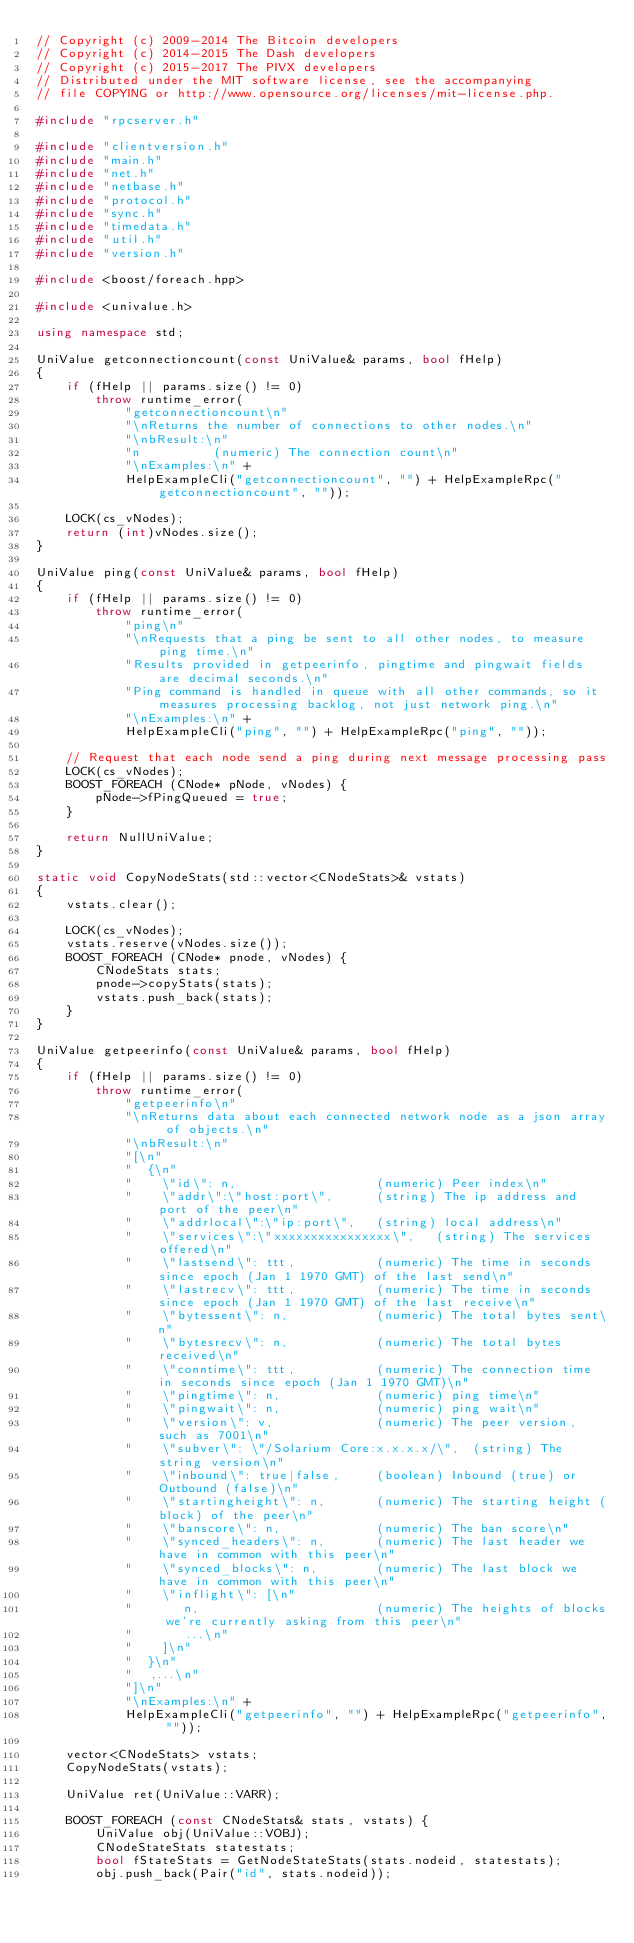Convert code to text. <code><loc_0><loc_0><loc_500><loc_500><_C++_>// Copyright (c) 2009-2014 The Bitcoin developers
// Copyright (c) 2014-2015 The Dash developers
// Copyright (c) 2015-2017 The PIVX developers
// Distributed under the MIT software license, see the accompanying
// file COPYING or http://www.opensource.org/licenses/mit-license.php.

#include "rpcserver.h"

#include "clientversion.h"
#include "main.h"
#include "net.h"
#include "netbase.h"
#include "protocol.h"
#include "sync.h"
#include "timedata.h"
#include "util.h"
#include "version.h"

#include <boost/foreach.hpp>

#include <univalue.h>

using namespace std;

UniValue getconnectioncount(const UniValue& params, bool fHelp)
{
    if (fHelp || params.size() != 0)
        throw runtime_error(
            "getconnectioncount\n"
            "\nReturns the number of connections to other nodes.\n"
            "\nbResult:\n"
            "n          (numeric) The connection count\n"
            "\nExamples:\n" +
            HelpExampleCli("getconnectioncount", "") + HelpExampleRpc("getconnectioncount", ""));

    LOCK(cs_vNodes);
    return (int)vNodes.size();
}

UniValue ping(const UniValue& params, bool fHelp)
{
    if (fHelp || params.size() != 0)
        throw runtime_error(
            "ping\n"
            "\nRequests that a ping be sent to all other nodes, to measure ping time.\n"
            "Results provided in getpeerinfo, pingtime and pingwait fields are decimal seconds.\n"
            "Ping command is handled in queue with all other commands, so it measures processing backlog, not just network ping.\n"
            "\nExamples:\n" +
            HelpExampleCli("ping", "") + HelpExampleRpc("ping", ""));

    // Request that each node send a ping during next message processing pass
    LOCK(cs_vNodes);
    BOOST_FOREACH (CNode* pNode, vNodes) {
        pNode->fPingQueued = true;
    }

    return NullUniValue;
}

static void CopyNodeStats(std::vector<CNodeStats>& vstats)
{
    vstats.clear();

    LOCK(cs_vNodes);
    vstats.reserve(vNodes.size());
    BOOST_FOREACH (CNode* pnode, vNodes) {
        CNodeStats stats;
        pnode->copyStats(stats);
        vstats.push_back(stats);
    }
}

UniValue getpeerinfo(const UniValue& params, bool fHelp)
{
    if (fHelp || params.size() != 0)
        throw runtime_error(
            "getpeerinfo\n"
            "\nReturns data about each connected network node as a json array of objects.\n"
            "\nbResult:\n"
            "[\n"
            "  {\n"
            "    \"id\": n,                   (numeric) Peer index\n"
            "    \"addr\":\"host:port\",      (string) The ip address and port of the peer\n"
            "    \"addrlocal\":\"ip:port\",   (string) local address\n"
            "    \"services\":\"xxxxxxxxxxxxxxxx\",   (string) The services offered\n"
            "    \"lastsend\": ttt,           (numeric) The time in seconds since epoch (Jan 1 1970 GMT) of the last send\n"
            "    \"lastrecv\": ttt,           (numeric) The time in seconds since epoch (Jan 1 1970 GMT) of the last receive\n"
            "    \"bytessent\": n,            (numeric) The total bytes sent\n"
            "    \"bytesrecv\": n,            (numeric) The total bytes received\n"
            "    \"conntime\": ttt,           (numeric) The connection time in seconds since epoch (Jan 1 1970 GMT)\n"
            "    \"pingtime\": n,             (numeric) ping time\n"
            "    \"pingwait\": n,             (numeric) ping wait\n"
            "    \"version\": v,              (numeric) The peer version, such as 7001\n"
            "    \"subver\": \"/Solarium Core:x.x.x.x/\",  (string) The string version\n"
            "    \"inbound\": true|false,     (boolean) Inbound (true) or Outbound (false)\n"
            "    \"startingheight\": n,       (numeric) The starting height (block) of the peer\n"
            "    \"banscore\": n,             (numeric) The ban score\n"
            "    \"synced_headers\": n,       (numeric) The last header we have in common with this peer\n"
            "    \"synced_blocks\": n,        (numeric) The last block we have in common with this peer\n"
            "    \"inflight\": [\n"
            "       n,                        (numeric) The heights of blocks we're currently asking from this peer\n"
            "       ...\n"
            "    ]\n"
            "  }\n"
            "  ,...\n"
            "]\n"
            "\nExamples:\n" +
            HelpExampleCli("getpeerinfo", "") + HelpExampleRpc("getpeerinfo", ""));

    vector<CNodeStats> vstats;
    CopyNodeStats(vstats);

    UniValue ret(UniValue::VARR);

    BOOST_FOREACH (const CNodeStats& stats, vstats) {
        UniValue obj(UniValue::VOBJ);
        CNodeStateStats statestats;
        bool fStateStats = GetNodeStateStats(stats.nodeid, statestats);
        obj.push_back(Pair("id", stats.nodeid));</code> 